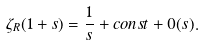<formula> <loc_0><loc_0><loc_500><loc_500>\zeta _ { R } ( 1 + s ) = \frac { 1 } { s } + c o n s t + 0 ( s ) .</formula> 